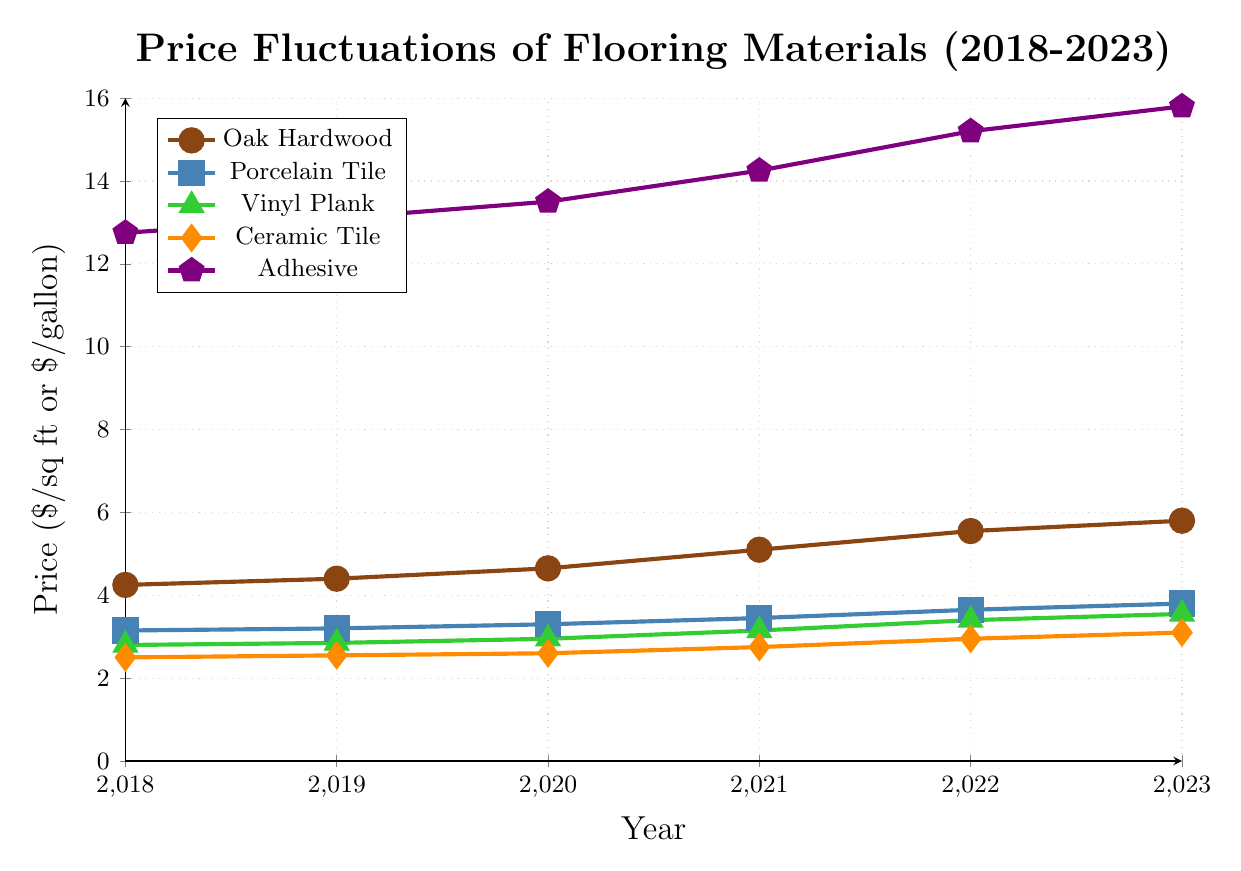What is the price of oak hardwood in 2020? Locate the year 2020 on the x-axis, then trace vertically until you meet the line representing oak hardwood, marked with a circle. The corresponding price is on the y-axis.
Answer: 4.65 Which material had the highest price increase from 2021 to 2023? Compare the price in 2021 to that in 2023 for each material. Oak Hardwood increased from 5.10 to 5.80, Porcelain Tile from 3.45 to 3.80, Vinyl Plank from 3.15 to 3.55, Ceramic Tile from 2.75 to 3.10, and Adhesive from 14.25 to 15.80. Calculate the difference for each and find the largest increase.
Answer: Adhesive In which year did adhesive see the largest increase in price compared to the previous year? Check the price changes year by year for adhesive. The prices are: 2018 - 12.75, 2019 - 13.10, 2020 - 13.50, 2021 - 14.25, 2022 - 15.20, 2023 - 15.80. Calculate the yearly differences: 2019: 0.35, 2020: 0.40, 2021: 0.75, 2022: 0.95, 2023: 0.60. Find the largest difference.
Answer: 2022 Which material has consistently increased in price every year? Check each material's prices over the years: Oak Hardwood (2018-2023): 4.25, 4.40, 4.65, 5.10, 5.55, 5.80; Porcelain Tile (2018-2023): 3.15, 3.20, 3.30, 3.45, 3.65, 3.80; Vinyl Plank (2018-2023): 2.80, 2.85, 2.95, 3.15, 3.40, 3.55; Ceramic Tile (2018-2023): 2.50, 2.55, 2.60, 2.75, 2.95, 3.10; Adhesive (2018-2023): 12.75, 13.10, 13.50, 14.25, 15.20, 15.80. All have increased every year.
Answer: All materials What was the combined price of vinyl plank and ceramic tile in 2018 and 2023? In 2018, the price of Vinyl Plank is 2.80 and Ceramic Tile is 2.50. Their combined price is 2.80 + 2.50 = 5.30. In 2023, Vinyl Plank is 3.55 and Ceramic Tile is 3.10. Their combined price is 3.55 + 3.10 = 6.65.
Answer: 5.30, 6.65 Did any material have a price below $3 per sq ft or gallon in 2023? Check the price of each material in 2023: Oak Hardwood is 5.80, Porcelain Tile is 3.80, Vinyl Plank is 3.55, Ceramic Tile is 3.10, Adhesive is 15.80. None are below $3.
Answer: No Between oak hardwood and porcelain tile, which had a smaller price increase from 2018 to 2023? Calculate the difference for both materials from 2018 to 2023. Oak Hardwood: 5.80 - 4.25 = 1.55, Porcelain Tile: 3.80 - 3.15 = 0.65. Porcelain Tile had a smaller increase.
Answer: Porcelain Tile What was the average price of ceramic tile over the 5 years? Calculate the average of ceramic tile’s prices: (2.50 + 2.55 + 2.60 + 2.75 + 2.95 + 3.10)/6 = 16.45/6 = 2.7417.
Answer: 2.74 By how much did the price of oak hardwood change from 2018 to 2021? Subtract the price of oak hardwood in 2018 from its price in 2021: 5.10 - 4.25 = 0.85.
Answer: 0.85 